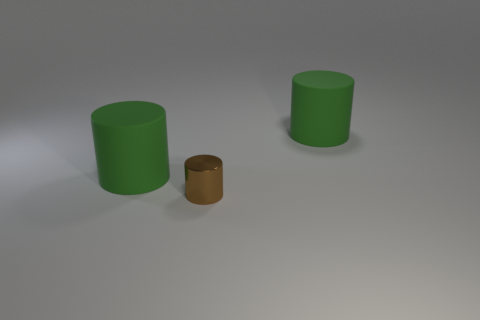Add 1 small brown metal things. How many objects exist? 4 Subtract all blue cylinders. Subtract all purple balls. How many cylinders are left? 3 Subtract all tiny brown objects. Subtract all green cylinders. How many objects are left? 0 Add 2 brown cylinders. How many brown cylinders are left? 3 Add 1 small purple things. How many small purple things exist? 1 Subtract 0 red cubes. How many objects are left? 3 